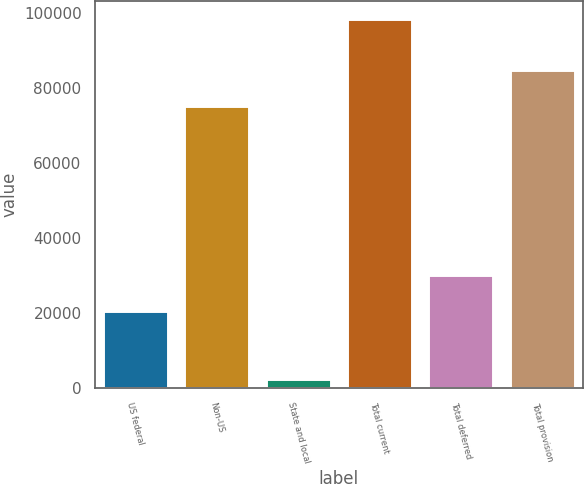Convert chart. <chart><loc_0><loc_0><loc_500><loc_500><bar_chart><fcel>US federal<fcel>Non-US<fcel>State and local<fcel>Total current<fcel>Total deferred<fcel>Total provision<nl><fcel>20569<fcel>75227<fcel>2612<fcel>98408<fcel>30148.6<fcel>84806.6<nl></chart> 